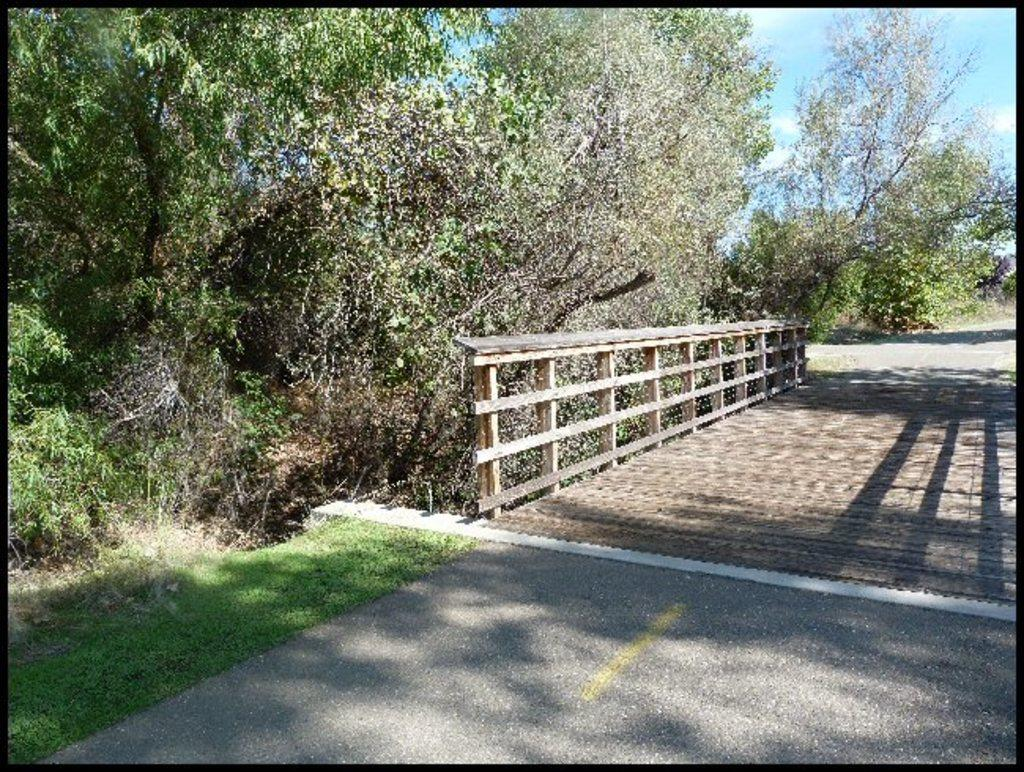What is the main feature of the image? There is a road in the image. What is located next to the road? There is a railing next to the road. What type of vegetation can be seen in the image? There are many trees in the image. What is visible in the background of the image? The sky is visible in the image. Can you describe the sky in the image? The sky is blue with clouds. What type of sign can be seen warning about an imminent attack in the image? There is no sign present in the image, nor is there any indication of an imminent attack. 